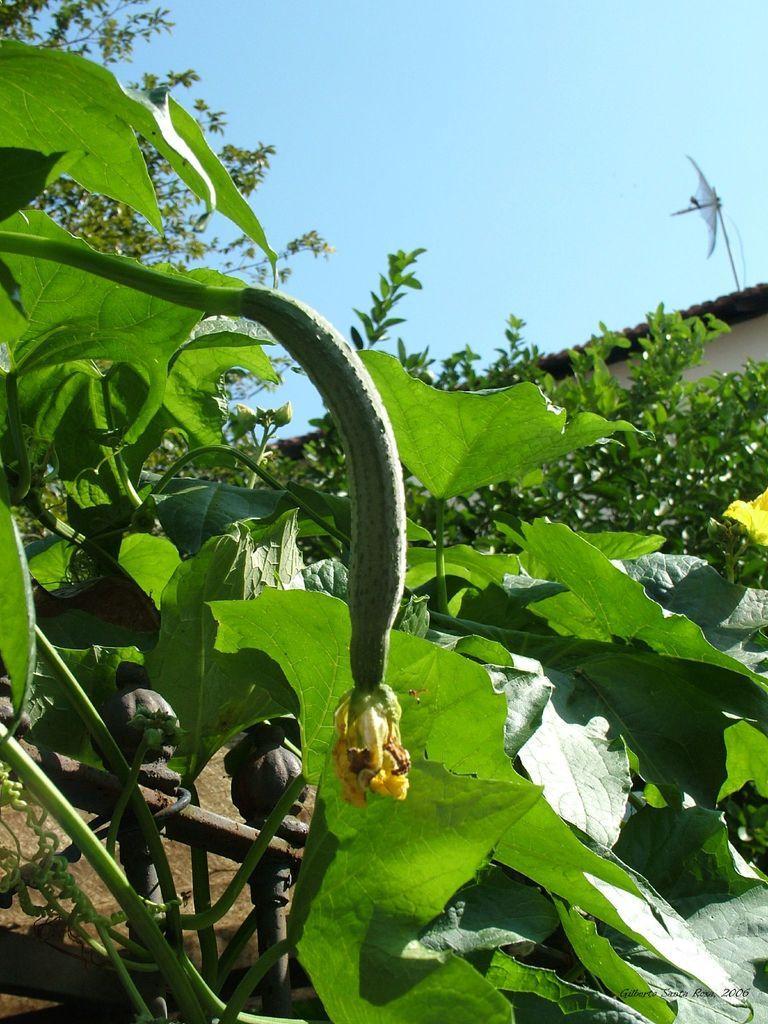In one or two sentences, can you explain what this image depicts? In the picture we can see the plants. Behind the plants, we can see a part of the house roof. In the background we can see the sky. 